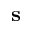<formula> <loc_0><loc_0><loc_500><loc_500>s</formula> 